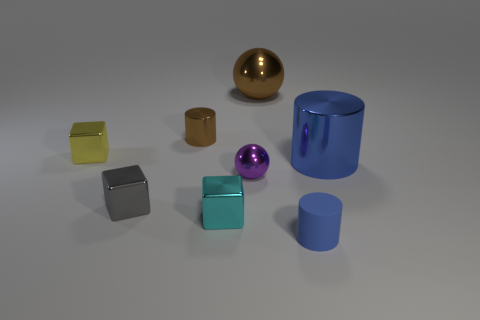What number of rubber things are big cylinders or brown balls?
Keep it short and to the point. 0. There is a small thing that is both in front of the blue metallic cylinder and behind the gray metallic cube; what color is it?
Offer a terse response. Purple. Do the metallic object left of the gray metal thing and the large blue metallic cylinder have the same size?
Make the answer very short. No. What number of things are metallic spheres that are right of the purple shiny ball or cyan things?
Your answer should be very brief. 2. Is there a ball that has the same size as the brown metal cylinder?
Your response must be concise. Yes. What is the material of the gray object that is the same size as the yellow cube?
Your answer should be compact. Metal. There is a small object that is both to the right of the brown cylinder and behind the tiny gray shiny object; what shape is it?
Your response must be concise. Sphere. The large metal object to the left of the blue matte cylinder is what color?
Your answer should be compact. Brown. There is a thing that is to the right of the large brown ball and in front of the big metal cylinder; what size is it?
Your response must be concise. Small. Is the material of the large blue thing the same as the small cylinder in front of the small yellow thing?
Your response must be concise. No. 